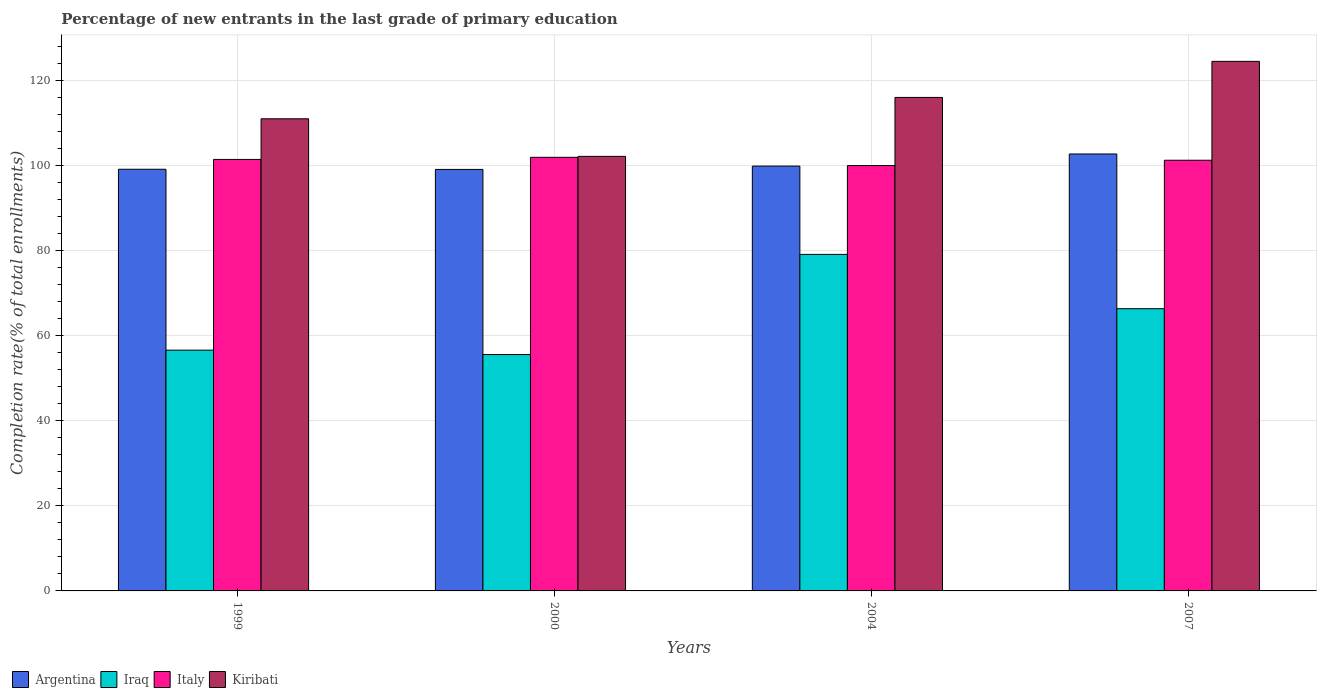How many groups of bars are there?
Your response must be concise. 4. Are the number of bars on each tick of the X-axis equal?
Offer a very short reply. Yes. How many bars are there on the 4th tick from the left?
Offer a very short reply. 4. How many bars are there on the 4th tick from the right?
Give a very brief answer. 4. What is the label of the 1st group of bars from the left?
Offer a very short reply. 1999. In how many cases, is the number of bars for a given year not equal to the number of legend labels?
Your answer should be compact. 0. What is the percentage of new entrants in Italy in 2000?
Offer a very short reply. 101.89. Across all years, what is the maximum percentage of new entrants in Iraq?
Your answer should be compact. 79.07. Across all years, what is the minimum percentage of new entrants in Iraq?
Your answer should be very brief. 55.54. In which year was the percentage of new entrants in Italy minimum?
Offer a terse response. 2004. What is the total percentage of new entrants in Iraq in the graph?
Offer a terse response. 257.51. What is the difference between the percentage of new entrants in Iraq in 2004 and that in 2007?
Make the answer very short. 12.76. What is the difference between the percentage of new entrants in Italy in 2000 and the percentage of new entrants in Kiribati in 1999?
Ensure brevity in your answer.  -9.05. What is the average percentage of new entrants in Kiribati per year?
Offer a very short reply. 113.36. In the year 1999, what is the difference between the percentage of new entrants in Argentina and percentage of new entrants in Iraq?
Your response must be concise. 42.5. In how many years, is the percentage of new entrants in Italy greater than 60 %?
Offer a terse response. 4. What is the ratio of the percentage of new entrants in Iraq in 1999 to that in 2007?
Keep it short and to the point. 0.85. Is the percentage of new entrants in Kiribati in 2000 less than that in 2007?
Offer a very short reply. Yes. Is the difference between the percentage of new entrants in Argentina in 1999 and 2007 greater than the difference between the percentage of new entrants in Iraq in 1999 and 2007?
Offer a very short reply. Yes. What is the difference between the highest and the second highest percentage of new entrants in Argentina?
Provide a short and direct response. 2.85. What is the difference between the highest and the lowest percentage of new entrants in Iraq?
Give a very brief answer. 23.53. In how many years, is the percentage of new entrants in Argentina greater than the average percentage of new entrants in Argentina taken over all years?
Provide a short and direct response. 1. Is the sum of the percentage of new entrants in Kiribati in 1999 and 2004 greater than the maximum percentage of new entrants in Iraq across all years?
Your answer should be very brief. Yes. What does the 1st bar from the left in 2004 represents?
Keep it short and to the point. Argentina. What does the 4th bar from the right in 1999 represents?
Give a very brief answer. Argentina. Are all the bars in the graph horizontal?
Your response must be concise. No. What is the difference between two consecutive major ticks on the Y-axis?
Offer a terse response. 20. Are the values on the major ticks of Y-axis written in scientific E-notation?
Ensure brevity in your answer.  No. Does the graph contain any zero values?
Offer a very short reply. No. Does the graph contain grids?
Keep it short and to the point. Yes. What is the title of the graph?
Your answer should be very brief. Percentage of new entrants in the last grade of primary education. Does "Ukraine" appear as one of the legend labels in the graph?
Your answer should be compact. No. What is the label or title of the Y-axis?
Make the answer very short. Completion rate(% of total enrollments). What is the Completion rate(% of total enrollments) in Argentina in 1999?
Your response must be concise. 99.08. What is the Completion rate(% of total enrollments) of Iraq in 1999?
Offer a very short reply. 56.58. What is the Completion rate(% of total enrollments) of Italy in 1999?
Offer a very short reply. 101.39. What is the Completion rate(% of total enrollments) in Kiribati in 1999?
Your response must be concise. 110.94. What is the Completion rate(% of total enrollments) of Argentina in 2000?
Provide a succinct answer. 99.04. What is the Completion rate(% of total enrollments) in Iraq in 2000?
Offer a very short reply. 55.54. What is the Completion rate(% of total enrollments) in Italy in 2000?
Your answer should be very brief. 101.89. What is the Completion rate(% of total enrollments) in Kiribati in 2000?
Offer a terse response. 102.11. What is the Completion rate(% of total enrollments) of Argentina in 2004?
Your answer should be very brief. 99.82. What is the Completion rate(% of total enrollments) in Iraq in 2004?
Give a very brief answer. 79.07. What is the Completion rate(% of total enrollments) in Italy in 2004?
Your answer should be compact. 99.95. What is the Completion rate(% of total enrollments) in Kiribati in 2004?
Your response must be concise. 115.96. What is the Completion rate(% of total enrollments) of Argentina in 2007?
Offer a terse response. 102.67. What is the Completion rate(% of total enrollments) of Iraq in 2007?
Keep it short and to the point. 66.32. What is the Completion rate(% of total enrollments) in Italy in 2007?
Your answer should be compact. 101.2. What is the Completion rate(% of total enrollments) of Kiribati in 2007?
Give a very brief answer. 124.43. Across all years, what is the maximum Completion rate(% of total enrollments) in Argentina?
Offer a very short reply. 102.67. Across all years, what is the maximum Completion rate(% of total enrollments) of Iraq?
Offer a terse response. 79.07. Across all years, what is the maximum Completion rate(% of total enrollments) in Italy?
Provide a succinct answer. 101.89. Across all years, what is the maximum Completion rate(% of total enrollments) of Kiribati?
Provide a short and direct response. 124.43. Across all years, what is the minimum Completion rate(% of total enrollments) in Argentina?
Provide a short and direct response. 99.04. Across all years, what is the minimum Completion rate(% of total enrollments) in Iraq?
Your response must be concise. 55.54. Across all years, what is the minimum Completion rate(% of total enrollments) of Italy?
Keep it short and to the point. 99.95. Across all years, what is the minimum Completion rate(% of total enrollments) of Kiribati?
Ensure brevity in your answer.  102.11. What is the total Completion rate(% of total enrollments) in Argentina in the graph?
Make the answer very short. 400.61. What is the total Completion rate(% of total enrollments) of Iraq in the graph?
Make the answer very short. 257.51. What is the total Completion rate(% of total enrollments) of Italy in the graph?
Make the answer very short. 404.43. What is the total Completion rate(% of total enrollments) in Kiribati in the graph?
Offer a terse response. 453.43. What is the difference between the Completion rate(% of total enrollments) of Argentina in 1999 and that in 2000?
Your answer should be very brief. 0.04. What is the difference between the Completion rate(% of total enrollments) in Iraq in 1999 and that in 2000?
Provide a succinct answer. 1.03. What is the difference between the Completion rate(% of total enrollments) of Italy in 1999 and that in 2000?
Make the answer very short. -0.5. What is the difference between the Completion rate(% of total enrollments) of Kiribati in 1999 and that in 2000?
Your response must be concise. 8.83. What is the difference between the Completion rate(% of total enrollments) of Argentina in 1999 and that in 2004?
Keep it short and to the point. -0.75. What is the difference between the Completion rate(% of total enrollments) in Iraq in 1999 and that in 2004?
Offer a terse response. -22.5. What is the difference between the Completion rate(% of total enrollments) of Italy in 1999 and that in 2004?
Offer a very short reply. 1.44. What is the difference between the Completion rate(% of total enrollments) in Kiribati in 1999 and that in 2004?
Keep it short and to the point. -5.02. What is the difference between the Completion rate(% of total enrollments) in Argentina in 1999 and that in 2007?
Give a very brief answer. -3.59. What is the difference between the Completion rate(% of total enrollments) of Iraq in 1999 and that in 2007?
Provide a short and direct response. -9.74. What is the difference between the Completion rate(% of total enrollments) of Italy in 1999 and that in 2007?
Your response must be concise. 0.19. What is the difference between the Completion rate(% of total enrollments) of Kiribati in 1999 and that in 2007?
Offer a terse response. -13.5. What is the difference between the Completion rate(% of total enrollments) in Argentina in 2000 and that in 2004?
Your answer should be compact. -0.78. What is the difference between the Completion rate(% of total enrollments) in Iraq in 2000 and that in 2004?
Make the answer very short. -23.53. What is the difference between the Completion rate(% of total enrollments) of Italy in 2000 and that in 2004?
Offer a very short reply. 1.93. What is the difference between the Completion rate(% of total enrollments) in Kiribati in 2000 and that in 2004?
Ensure brevity in your answer.  -13.85. What is the difference between the Completion rate(% of total enrollments) of Argentina in 2000 and that in 2007?
Give a very brief answer. -3.63. What is the difference between the Completion rate(% of total enrollments) of Iraq in 2000 and that in 2007?
Offer a terse response. -10.77. What is the difference between the Completion rate(% of total enrollments) in Italy in 2000 and that in 2007?
Provide a short and direct response. 0.69. What is the difference between the Completion rate(% of total enrollments) in Kiribati in 2000 and that in 2007?
Ensure brevity in your answer.  -22.33. What is the difference between the Completion rate(% of total enrollments) in Argentina in 2004 and that in 2007?
Make the answer very short. -2.85. What is the difference between the Completion rate(% of total enrollments) of Iraq in 2004 and that in 2007?
Your response must be concise. 12.76. What is the difference between the Completion rate(% of total enrollments) of Italy in 2004 and that in 2007?
Provide a succinct answer. -1.25. What is the difference between the Completion rate(% of total enrollments) of Kiribati in 2004 and that in 2007?
Make the answer very short. -8.48. What is the difference between the Completion rate(% of total enrollments) in Argentina in 1999 and the Completion rate(% of total enrollments) in Iraq in 2000?
Your response must be concise. 43.54. What is the difference between the Completion rate(% of total enrollments) in Argentina in 1999 and the Completion rate(% of total enrollments) in Italy in 2000?
Make the answer very short. -2.81. What is the difference between the Completion rate(% of total enrollments) in Argentina in 1999 and the Completion rate(% of total enrollments) in Kiribati in 2000?
Offer a very short reply. -3.03. What is the difference between the Completion rate(% of total enrollments) of Iraq in 1999 and the Completion rate(% of total enrollments) of Italy in 2000?
Your answer should be compact. -45.31. What is the difference between the Completion rate(% of total enrollments) in Iraq in 1999 and the Completion rate(% of total enrollments) in Kiribati in 2000?
Offer a terse response. -45.53. What is the difference between the Completion rate(% of total enrollments) in Italy in 1999 and the Completion rate(% of total enrollments) in Kiribati in 2000?
Give a very brief answer. -0.72. What is the difference between the Completion rate(% of total enrollments) in Argentina in 1999 and the Completion rate(% of total enrollments) in Iraq in 2004?
Make the answer very short. 20. What is the difference between the Completion rate(% of total enrollments) of Argentina in 1999 and the Completion rate(% of total enrollments) of Italy in 2004?
Ensure brevity in your answer.  -0.87. What is the difference between the Completion rate(% of total enrollments) in Argentina in 1999 and the Completion rate(% of total enrollments) in Kiribati in 2004?
Provide a succinct answer. -16.88. What is the difference between the Completion rate(% of total enrollments) of Iraq in 1999 and the Completion rate(% of total enrollments) of Italy in 2004?
Ensure brevity in your answer.  -43.38. What is the difference between the Completion rate(% of total enrollments) in Iraq in 1999 and the Completion rate(% of total enrollments) in Kiribati in 2004?
Your response must be concise. -59.38. What is the difference between the Completion rate(% of total enrollments) of Italy in 1999 and the Completion rate(% of total enrollments) of Kiribati in 2004?
Your response must be concise. -14.57. What is the difference between the Completion rate(% of total enrollments) in Argentina in 1999 and the Completion rate(% of total enrollments) in Iraq in 2007?
Your response must be concise. 32.76. What is the difference between the Completion rate(% of total enrollments) in Argentina in 1999 and the Completion rate(% of total enrollments) in Italy in 2007?
Make the answer very short. -2.12. What is the difference between the Completion rate(% of total enrollments) of Argentina in 1999 and the Completion rate(% of total enrollments) of Kiribati in 2007?
Provide a succinct answer. -25.36. What is the difference between the Completion rate(% of total enrollments) in Iraq in 1999 and the Completion rate(% of total enrollments) in Italy in 2007?
Ensure brevity in your answer.  -44.62. What is the difference between the Completion rate(% of total enrollments) in Iraq in 1999 and the Completion rate(% of total enrollments) in Kiribati in 2007?
Your answer should be compact. -67.86. What is the difference between the Completion rate(% of total enrollments) in Italy in 1999 and the Completion rate(% of total enrollments) in Kiribati in 2007?
Provide a short and direct response. -23.04. What is the difference between the Completion rate(% of total enrollments) in Argentina in 2000 and the Completion rate(% of total enrollments) in Iraq in 2004?
Give a very brief answer. 19.96. What is the difference between the Completion rate(% of total enrollments) in Argentina in 2000 and the Completion rate(% of total enrollments) in Italy in 2004?
Your response must be concise. -0.91. What is the difference between the Completion rate(% of total enrollments) in Argentina in 2000 and the Completion rate(% of total enrollments) in Kiribati in 2004?
Your response must be concise. -16.92. What is the difference between the Completion rate(% of total enrollments) in Iraq in 2000 and the Completion rate(% of total enrollments) in Italy in 2004?
Make the answer very short. -44.41. What is the difference between the Completion rate(% of total enrollments) of Iraq in 2000 and the Completion rate(% of total enrollments) of Kiribati in 2004?
Provide a succinct answer. -60.41. What is the difference between the Completion rate(% of total enrollments) in Italy in 2000 and the Completion rate(% of total enrollments) in Kiribati in 2004?
Provide a succinct answer. -14.07. What is the difference between the Completion rate(% of total enrollments) of Argentina in 2000 and the Completion rate(% of total enrollments) of Iraq in 2007?
Keep it short and to the point. 32.72. What is the difference between the Completion rate(% of total enrollments) in Argentina in 2000 and the Completion rate(% of total enrollments) in Italy in 2007?
Your answer should be very brief. -2.16. What is the difference between the Completion rate(% of total enrollments) of Argentina in 2000 and the Completion rate(% of total enrollments) of Kiribati in 2007?
Your answer should be very brief. -25.39. What is the difference between the Completion rate(% of total enrollments) of Iraq in 2000 and the Completion rate(% of total enrollments) of Italy in 2007?
Your response must be concise. -45.66. What is the difference between the Completion rate(% of total enrollments) in Iraq in 2000 and the Completion rate(% of total enrollments) in Kiribati in 2007?
Ensure brevity in your answer.  -68.89. What is the difference between the Completion rate(% of total enrollments) in Italy in 2000 and the Completion rate(% of total enrollments) in Kiribati in 2007?
Keep it short and to the point. -22.55. What is the difference between the Completion rate(% of total enrollments) of Argentina in 2004 and the Completion rate(% of total enrollments) of Iraq in 2007?
Ensure brevity in your answer.  33.51. What is the difference between the Completion rate(% of total enrollments) of Argentina in 2004 and the Completion rate(% of total enrollments) of Italy in 2007?
Provide a succinct answer. -1.38. What is the difference between the Completion rate(% of total enrollments) in Argentina in 2004 and the Completion rate(% of total enrollments) in Kiribati in 2007?
Offer a very short reply. -24.61. What is the difference between the Completion rate(% of total enrollments) in Iraq in 2004 and the Completion rate(% of total enrollments) in Italy in 2007?
Give a very brief answer. -22.12. What is the difference between the Completion rate(% of total enrollments) of Iraq in 2004 and the Completion rate(% of total enrollments) of Kiribati in 2007?
Offer a very short reply. -45.36. What is the difference between the Completion rate(% of total enrollments) in Italy in 2004 and the Completion rate(% of total enrollments) in Kiribati in 2007?
Give a very brief answer. -24.48. What is the average Completion rate(% of total enrollments) in Argentina per year?
Provide a succinct answer. 100.15. What is the average Completion rate(% of total enrollments) of Iraq per year?
Provide a short and direct response. 64.38. What is the average Completion rate(% of total enrollments) of Italy per year?
Provide a short and direct response. 101.11. What is the average Completion rate(% of total enrollments) in Kiribati per year?
Provide a succinct answer. 113.36. In the year 1999, what is the difference between the Completion rate(% of total enrollments) of Argentina and Completion rate(% of total enrollments) of Iraq?
Your answer should be compact. 42.5. In the year 1999, what is the difference between the Completion rate(% of total enrollments) in Argentina and Completion rate(% of total enrollments) in Italy?
Give a very brief answer. -2.31. In the year 1999, what is the difference between the Completion rate(% of total enrollments) of Argentina and Completion rate(% of total enrollments) of Kiribati?
Keep it short and to the point. -11.86. In the year 1999, what is the difference between the Completion rate(% of total enrollments) in Iraq and Completion rate(% of total enrollments) in Italy?
Offer a very short reply. -44.81. In the year 1999, what is the difference between the Completion rate(% of total enrollments) of Iraq and Completion rate(% of total enrollments) of Kiribati?
Your answer should be very brief. -54.36. In the year 1999, what is the difference between the Completion rate(% of total enrollments) in Italy and Completion rate(% of total enrollments) in Kiribati?
Your answer should be very brief. -9.55. In the year 2000, what is the difference between the Completion rate(% of total enrollments) of Argentina and Completion rate(% of total enrollments) of Iraq?
Make the answer very short. 43.5. In the year 2000, what is the difference between the Completion rate(% of total enrollments) in Argentina and Completion rate(% of total enrollments) in Italy?
Keep it short and to the point. -2.85. In the year 2000, what is the difference between the Completion rate(% of total enrollments) of Argentina and Completion rate(% of total enrollments) of Kiribati?
Keep it short and to the point. -3.07. In the year 2000, what is the difference between the Completion rate(% of total enrollments) in Iraq and Completion rate(% of total enrollments) in Italy?
Your response must be concise. -46.34. In the year 2000, what is the difference between the Completion rate(% of total enrollments) of Iraq and Completion rate(% of total enrollments) of Kiribati?
Make the answer very short. -46.57. In the year 2000, what is the difference between the Completion rate(% of total enrollments) of Italy and Completion rate(% of total enrollments) of Kiribati?
Provide a short and direct response. -0.22. In the year 2004, what is the difference between the Completion rate(% of total enrollments) of Argentina and Completion rate(% of total enrollments) of Iraq?
Offer a terse response. 20.75. In the year 2004, what is the difference between the Completion rate(% of total enrollments) in Argentina and Completion rate(% of total enrollments) in Italy?
Ensure brevity in your answer.  -0.13. In the year 2004, what is the difference between the Completion rate(% of total enrollments) of Argentina and Completion rate(% of total enrollments) of Kiribati?
Make the answer very short. -16.13. In the year 2004, what is the difference between the Completion rate(% of total enrollments) in Iraq and Completion rate(% of total enrollments) in Italy?
Offer a very short reply. -20.88. In the year 2004, what is the difference between the Completion rate(% of total enrollments) of Iraq and Completion rate(% of total enrollments) of Kiribati?
Provide a short and direct response. -36.88. In the year 2004, what is the difference between the Completion rate(% of total enrollments) of Italy and Completion rate(% of total enrollments) of Kiribati?
Provide a short and direct response. -16. In the year 2007, what is the difference between the Completion rate(% of total enrollments) in Argentina and Completion rate(% of total enrollments) in Iraq?
Keep it short and to the point. 36.35. In the year 2007, what is the difference between the Completion rate(% of total enrollments) in Argentina and Completion rate(% of total enrollments) in Italy?
Your answer should be compact. 1.47. In the year 2007, what is the difference between the Completion rate(% of total enrollments) of Argentina and Completion rate(% of total enrollments) of Kiribati?
Your answer should be very brief. -21.76. In the year 2007, what is the difference between the Completion rate(% of total enrollments) in Iraq and Completion rate(% of total enrollments) in Italy?
Provide a succinct answer. -34.88. In the year 2007, what is the difference between the Completion rate(% of total enrollments) in Iraq and Completion rate(% of total enrollments) in Kiribati?
Give a very brief answer. -58.12. In the year 2007, what is the difference between the Completion rate(% of total enrollments) in Italy and Completion rate(% of total enrollments) in Kiribati?
Keep it short and to the point. -23.23. What is the ratio of the Completion rate(% of total enrollments) in Argentina in 1999 to that in 2000?
Give a very brief answer. 1. What is the ratio of the Completion rate(% of total enrollments) of Iraq in 1999 to that in 2000?
Provide a succinct answer. 1.02. What is the ratio of the Completion rate(% of total enrollments) in Kiribati in 1999 to that in 2000?
Provide a succinct answer. 1.09. What is the ratio of the Completion rate(% of total enrollments) of Iraq in 1999 to that in 2004?
Your response must be concise. 0.72. What is the ratio of the Completion rate(% of total enrollments) in Italy in 1999 to that in 2004?
Ensure brevity in your answer.  1.01. What is the ratio of the Completion rate(% of total enrollments) of Kiribati in 1999 to that in 2004?
Offer a very short reply. 0.96. What is the ratio of the Completion rate(% of total enrollments) of Iraq in 1999 to that in 2007?
Your response must be concise. 0.85. What is the ratio of the Completion rate(% of total enrollments) of Italy in 1999 to that in 2007?
Offer a terse response. 1. What is the ratio of the Completion rate(% of total enrollments) in Kiribati in 1999 to that in 2007?
Ensure brevity in your answer.  0.89. What is the ratio of the Completion rate(% of total enrollments) in Argentina in 2000 to that in 2004?
Provide a short and direct response. 0.99. What is the ratio of the Completion rate(% of total enrollments) in Iraq in 2000 to that in 2004?
Your answer should be very brief. 0.7. What is the ratio of the Completion rate(% of total enrollments) in Italy in 2000 to that in 2004?
Your response must be concise. 1.02. What is the ratio of the Completion rate(% of total enrollments) in Kiribati in 2000 to that in 2004?
Give a very brief answer. 0.88. What is the ratio of the Completion rate(% of total enrollments) of Argentina in 2000 to that in 2007?
Provide a succinct answer. 0.96. What is the ratio of the Completion rate(% of total enrollments) in Iraq in 2000 to that in 2007?
Your response must be concise. 0.84. What is the ratio of the Completion rate(% of total enrollments) in Italy in 2000 to that in 2007?
Your answer should be compact. 1.01. What is the ratio of the Completion rate(% of total enrollments) of Kiribati in 2000 to that in 2007?
Give a very brief answer. 0.82. What is the ratio of the Completion rate(% of total enrollments) of Argentina in 2004 to that in 2007?
Your answer should be very brief. 0.97. What is the ratio of the Completion rate(% of total enrollments) of Iraq in 2004 to that in 2007?
Keep it short and to the point. 1.19. What is the ratio of the Completion rate(% of total enrollments) of Kiribati in 2004 to that in 2007?
Make the answer very short. 0.93. What is the difference between the highest and the second highest Completion rate(% of total enrollments) of Argentina?
Your response must be concise. 2.85. What is the difference between the highest and the second highest Completion rate(% of total enrollments) of Iraq?
Provide a short and direct response. 12.76. What is the difference between the highest and the second highest Completion rate(% of total enrollments) in Italy?
Make the answer very short. 0.5. What is the difference between the highest and the second highest Completion rate(% of total enrollments) in Kiribati?
Keep it short and to the point. 8.48. What is the difference between the highest and the lowest Completion rate(% of total enrollments) in Argentina?
Keep it short and to the point. 3.63. What is the difference between the highest and the lowest Completion rate(% of total enrollments) of Iraq?
Offer a very short reply. 23.53. What is the difference between the highest and the lowest Completion rate(% of total enrollments) in Italy?
Your answer should be very brief. 1.93. What is the difference between the highest and the lowest Completion rate(% of total enrollments) in Kiribati?
Your response must be concise. 22.33. 